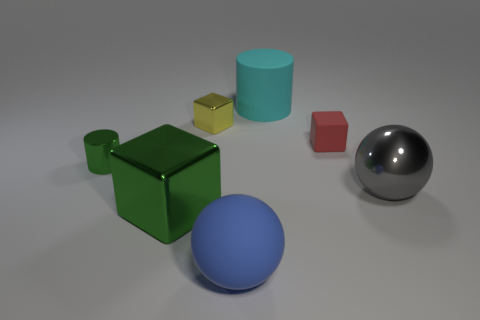Add 3 cyan rubber spheres. How many objects exist? 10 Subtract all cylinders. How many objects are left? 5 Subtract all matte cylinders. Subtract all tiny brown shiny spheres. How many objects are left? 6 Add 3 yellow cubes. How many yellow cubes are left? 4 Add 1 rubber cylinders. How many rubber cylinders exist? 2 Subtract 0 red balls. How many objects are left? 7 